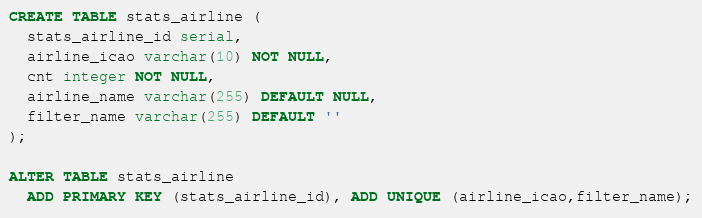Convert code to text. <code><loc_0><loc_0><loc_500><loc_500><_SQL_>CREATE TABLE stats_airline (
  stats_airline_id serial,
  airline_icao varchar(10) NOT NULL,
  cnt integer NOT NULL,
  airline_name varchar(255) DEFAULT NULL,
  filter_name varchar(255) DEFAULT ''
);

ALTER TABLE stats_airline
  ADD PRIMARY KEY (stats_airline_id), ADD UNIQUE (airline_icao,filter_name);
</code> 